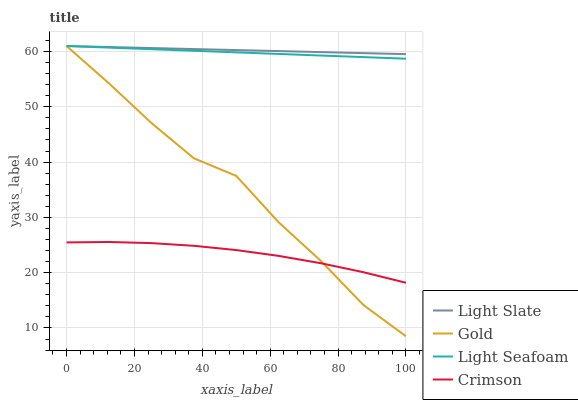Does Crimson have the minimum area under the curve?
Answer yes or no. Yes. Does Light Slate have the maximum area under the curve?
Answer yes or no. Yes. Does Light Seafoam have the minimum area under the curve?
Answer yes or no. No. Does Light Seafoam have the maximum area under the curve?
Answer yes or no. No. Is Light Slate the smoothest?
Answer yes or no. Yes. Is Gold the roughest?
Answer yes or no. Yes. Is Crimson the smoothest?
Answer yes or no. No. Is Crimson the roughest?
Answer yes or no. No. Does Crimson have the lowest value?
Answer yes or no. No. Does Gold have the highest value?
Answer yes or no. Yes. Does Crimson have the highest value?
Answer yes or no. No. Is Crimson less than Light Slate?
Answer yes or no. Yes. Is Light Seafoam greater than Crimson?
Answer yes or no. Yes. Does Gold intersect Light Seafoam?
Answer yes or no. Yes. Is Gold less than Light Seafoam?
Answer yes or no. No. Is Gold greater than Light Seafoam?
Answer yes or no. No. Does Crimson intersect Light Slate?
Answer yes or no. No. 